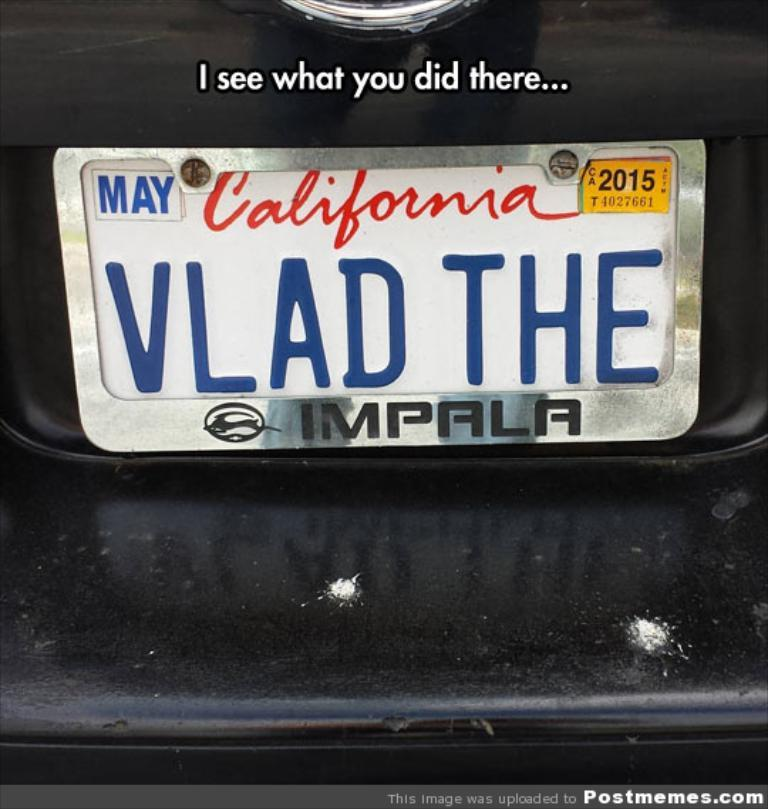<image>
Summarize the visual content of the image. White California license plate that says VLAD THE on it. 